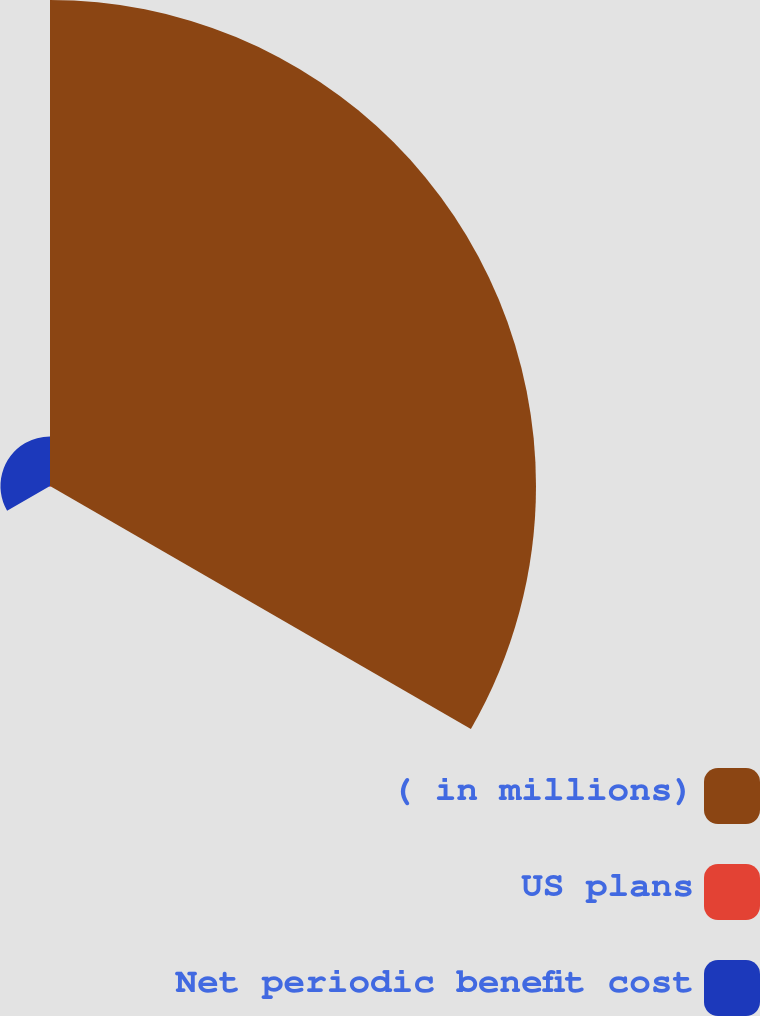Convert chart to OTSL. <chart><loc_0><loc_0><loc_500><loc_500><pie_chart><fcel>( in millions)<fcel>US plans<fcel>Net periodic benefit cost<nl><fcel>90.57%<fcel>0.19%<fcel>9.23%<nl></chart> 